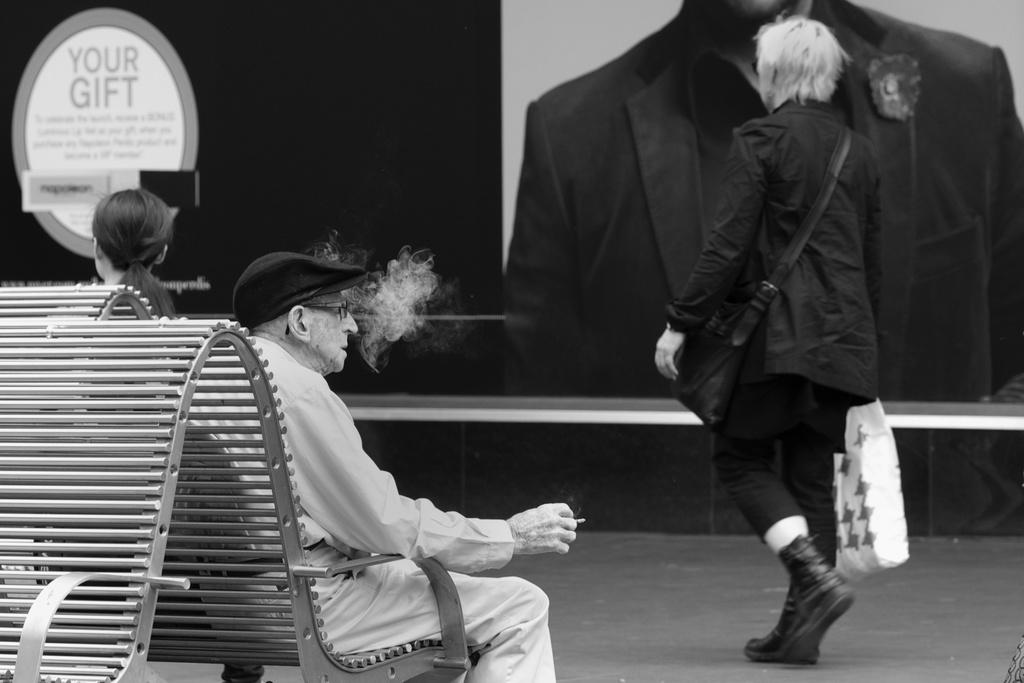How many people are in the image? There are three persons in the image. What type of seating is visible in the image? There are benches in the image. What can be seen in the background of the image? There is a hoarding in the background of the image. What type of vest is the person on the left wearing in the image? There is no vest visible on any of the persons in the image. What cause is the person in the middle advocating for in the image? There is no indication of any cause or advocacy in the image; it simply shows three persons and benches. 